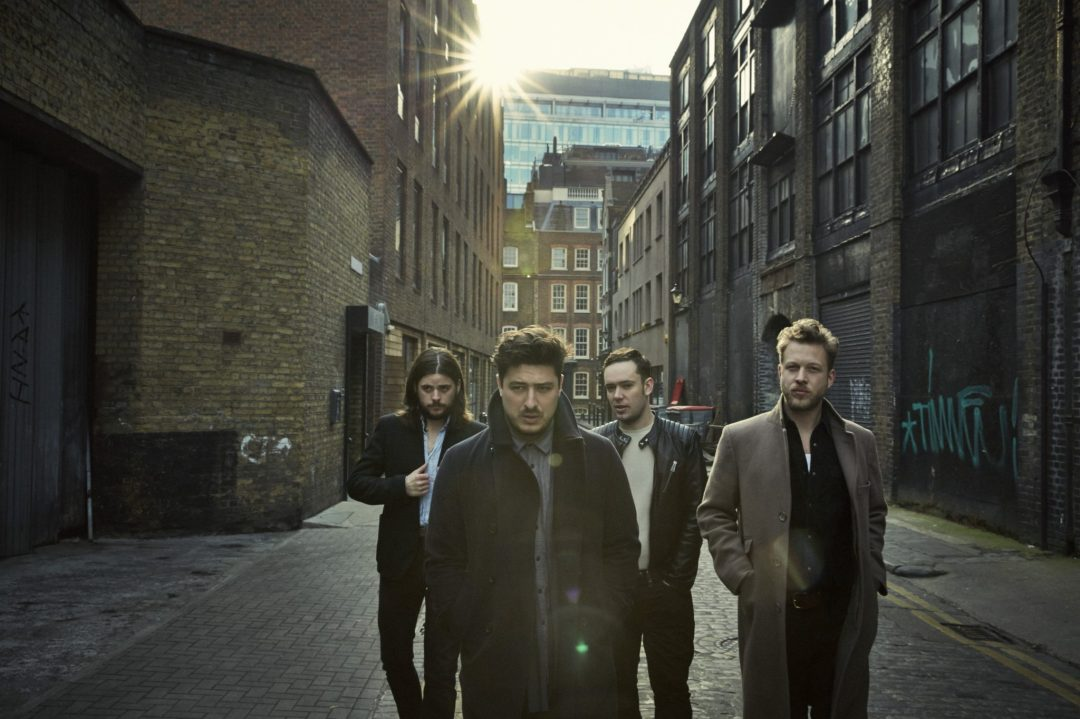Based on the attire and grooming styles of the individuals in the image, what time of year does it appear to be and what might be the group's purpose for being in this alleyway? The attire of the individuals, consisting of coats and jackets, suggests that it is likely a cooler time of year, possibly autumn or spring. Given their coordinated fashion and serious expressions, they could be part of a band or a group involved in a creative project, such as a photoshoot or a music video, using the urban alleyway as a backdrop for its aesthetic appeal. 